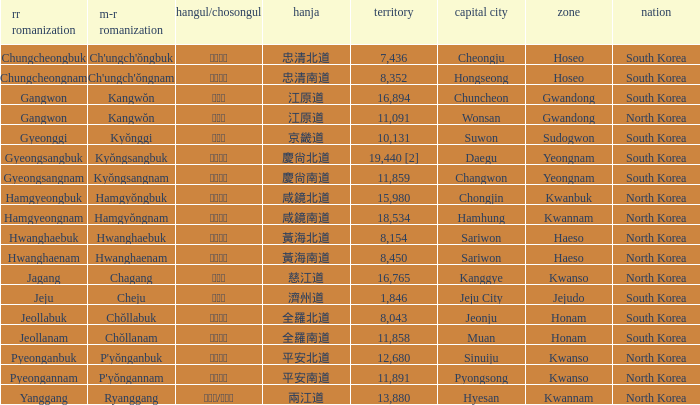Write the full table. {'header': ['rr romanization', 'm-r romanization', 'hangul/chosongul', 'hanja', 'territory', 'capital city', 'zone', 'nation'], 'rows': [['Chungcheongbuk', "Ch'ungch'ŏngbuk", '충청북도', '忠清北道', '7,436', 'Cheongju', 'Hoseo', 'South Korea'], ['Chungcheongnam', "Ch'ungch'ŏngnam", '충청남도', '忠清南道', '8,352', 'Hongseong', 'Hoseo', 'South Korea'], ['Gangwon', 'Kangwŏn', '강원도', '江原道', '16,894', 'Chuncheon', 'Gwandong', 'South Korea'], ['Gangwon', 'Kangwŏn', '강원도', '江原道', '11,091', 'Wonsan', 'Gwandong', 'North Korea'], ['Gyeonggi', 'Kyŏnggi', '경기도', '京畿道', '10,131', 'Suwon', 'Sudogwon', 'South Korea'], ['Gyeongsangbuk', 'Kyŏngsangbuk', '경상북도', '慶尙北道', '19,440 [2]', 'Daegu', 'Yeongnam', 'South Korea'], ['Gyeongsangnam', 'Kyŏngsangnam', '경상남도', '慶尙南道', '11,859', 'Changwon', 'Yeongnam', 'South Korea'], ['Hamgyeongbuk', 'Hamgyŏngbuk', '함경북도', '咸鏡北道', '15,980', 'Chongjin', 'Kwanbuk', 'North Korea'], ['Hamgyeongnam', 'Hamgyŏngnam', '함경남도', '咸鏡南道', '18,534', 'Hamhung', 'Kwannam', 'North Korea'], ['Hwanghaebuk', 'Hwanghaebuk', '황해북도', '黃海北道', '8,154', 'Sariwon', 'Haeso', 'North Korea'], ['Hwanghaenam', 'Hwanghaenam', '황해남도', '黃海南道', '8,450', 'Sariwon', 'Haeso', 'North Korea'], ['Jagang', 'Chagang', '자강도', '慈江道', '16,765', 'Kanggye', 'Kwanso', 'North Korea'], ['Jeju', 'Cheju', '제주도', '濟州道', '1,846', 'Jeju City', 'Jejudo', 'South Korea'], ['Jeollabuk', 'Chŏllabuk', '전라북도', '全羅北道', '8,043', 'Jeonju', 'Honam', 'South Korea'], ['Jeollanam', 'Chŏllanam', '전라남도', '全羅南道', '11,858', 'Muan', 'Honam', 'South Korea'], ['Pyeonganbuk', "P'yŏnganbuk", '평안북도', '平安北道', '12,680', 'Sinuiju', 'Kwanso', 'North Korea'], ['Pyeongannam', "P'yŏngannam", '평안남도', '平安南道', '11,891', 'Pyongsong', 'Kwanso', 'North Korea'], ['Yanggang', 'Ryanggang', '량강도/양강도', '兩江道', '13,880', 'Hyesan', 'Kwannam', 'North Korea']]} What is the M-R Romaja for the province having a capital of Cheongju? Ch'ungch'ŏngbuk. 